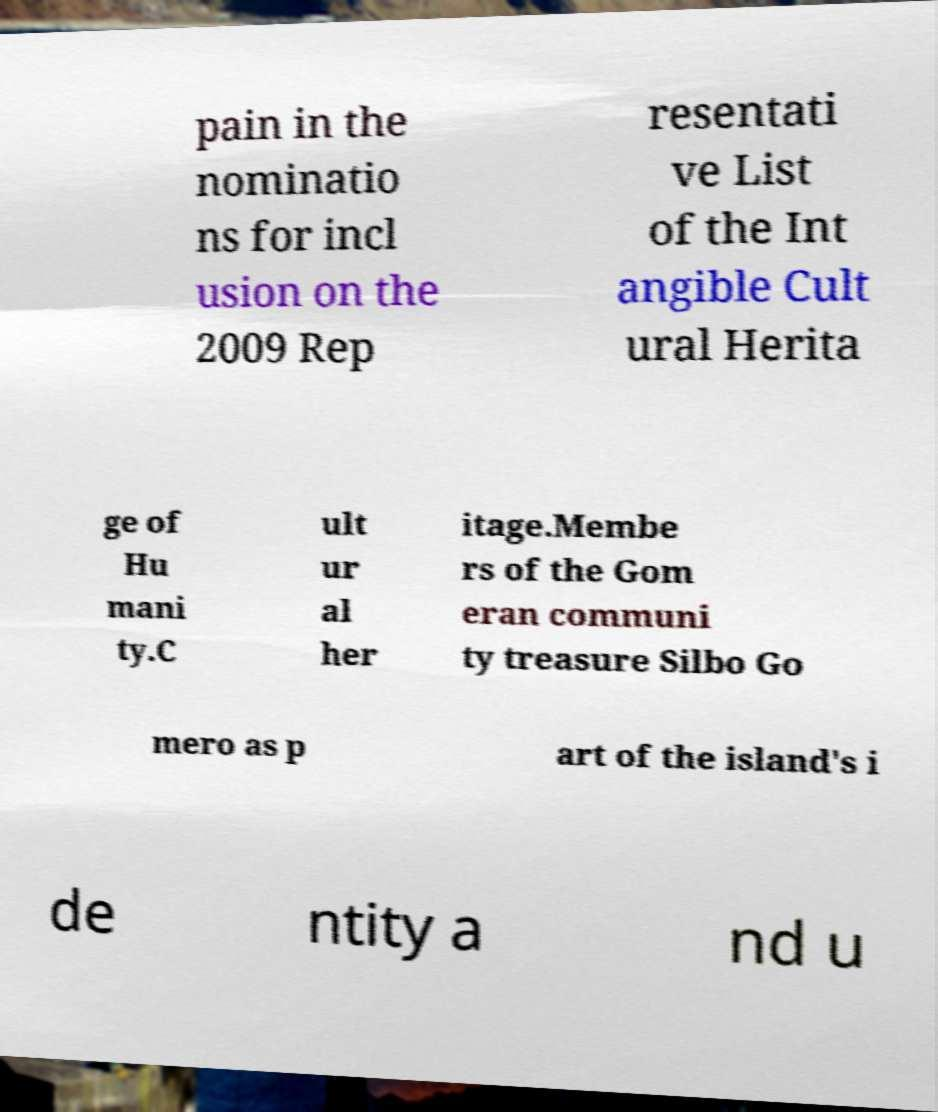What messages or text are displayed in this image? I need them in a readable, typed format. pain in the nominatio ns for incl usion on the 2009 Rep resentati ve List of the Int angible Cult ural Herita ge of Hu mani ty.C ult ur al her itage.Membe rs of the Gom eran communi ty treasure Silbo Go mero as p art of the island's i de ntity a nd u 